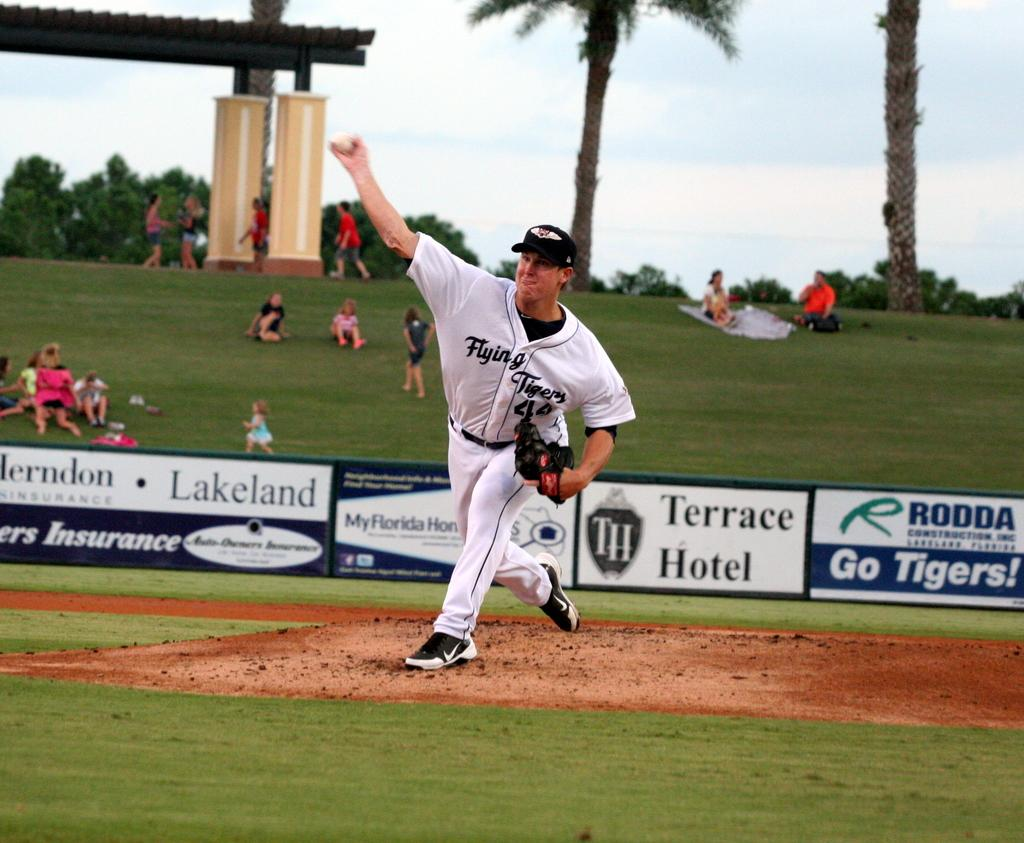Provide a one-sentence caption for the provided image. A pitcher is throwing a ball at a baseball game sponsored by Terrace Hotel. 